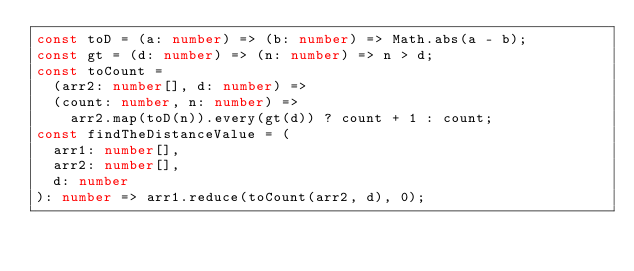<code> <loc_0><loc_0><loc_500><loc_500><_TypeScript_>const toD = (a: number) => (b: number) => Math.abs(a - b);
const gt = (d: number) => (n: number) => n > d;
const toCount =
  (arr2: number[], d: number) =>
  (count: number, n: number) =>
    arr2.map(toD(n)).every(gt(d)) ? count + 1 : count;
const findTheDistanceValue = (
  arr1: number[],
  arr2: number[],
  d: number
): number => arr1.reduce(toCount(arr2, d), 0);
</code> 